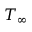Convert formula to latex. <formula><loc_0><loc_0><loc_500><loc_500>T _ { \infty }</formula> 